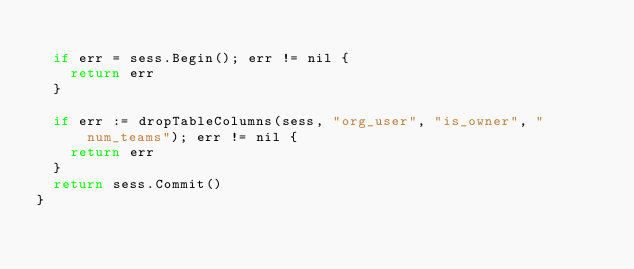<code> <loc_0><loc_0><loc_500><loc_500><_Go_>
	if err = sess.Begin(); err != nil {
		return err
	}

	if err := dropTableColumns(sess, "org_user", "is_owner", "num_teams"); err != nil {
		return err
	}
	return sess.Commit()
}
</code> 